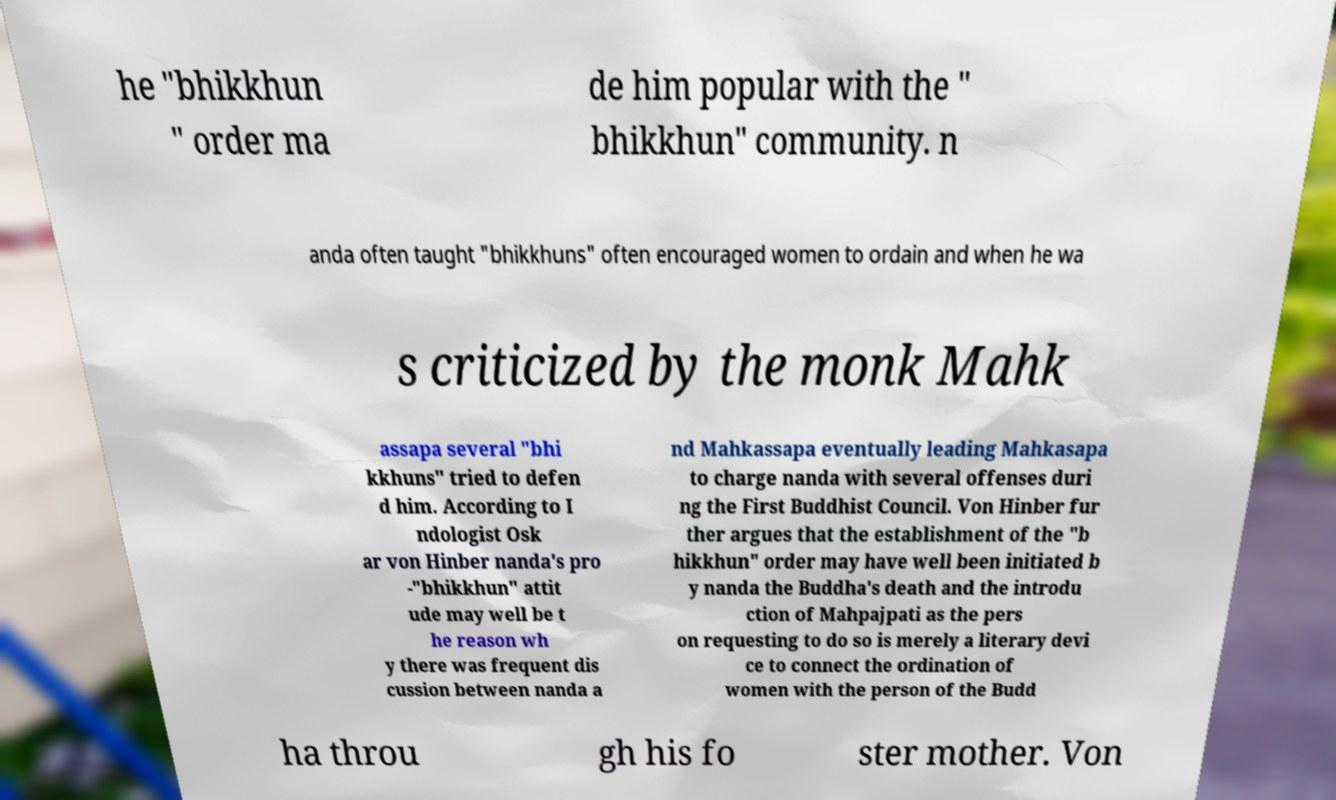Could you assist in decoding the text presented in this image and type it out clearly? he "bhikkhun " order ma de him popular with the " bhikkhun" community. n anda often taught "bhikkhuns" often encouraged women to ordain and when he wa s criticized by the monk Mahk assapa several "bhi kkhuns" tried to defen d him. According to I ndologist Osk ar von Hinber nanda's pro -"bhikkhun" attit ude may well be t he reason wh y there was frequent dis cussion between nanda a nd Mahkassapa eventually leading Mahkasapa to charge nanda with several offenses duri ng the First Buddhist Council. Von Hinber fur ther argues that the establishment of the "b hikkhun" order may have well been initiated b y nanda the Buddha's death and the introdu ction of Mahpajpati as the pers on requesting to do so is merely a literary devi ce to connect the ordination of women with the person of the Budd ha throu gh his fo ster mother. Von 